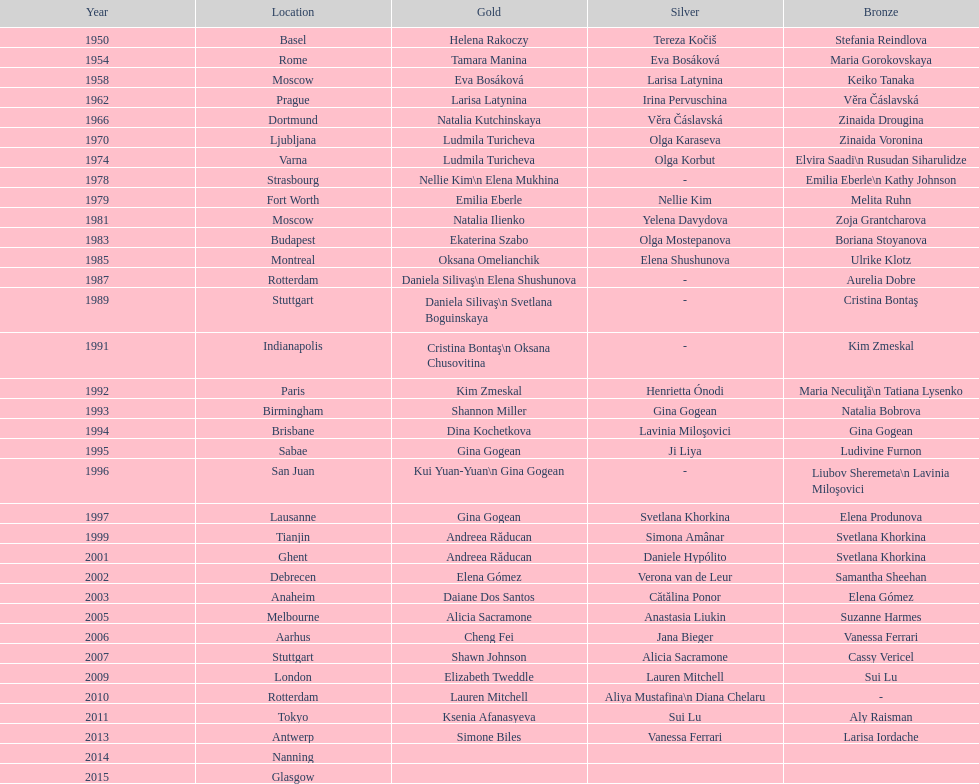How many times was the world artistic gymnastics championships held in the united states? 3. 